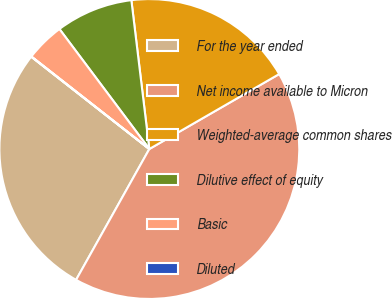<chart> <loc_0><loc_0><loc_500><loc_500><pie_chart><fcel>For the year ended<fcel>Net income available to Micron<fcel>Weighted-average common shares<fcel>Dilutive effect of equity<fcel>Basic<fcel>Diluted<nl><fcel>27.43%<fcel>41.45%<fcel>18.58%<fcel>8.32%<fcel>4.18%<fcel>0.03%<nl></chart> 